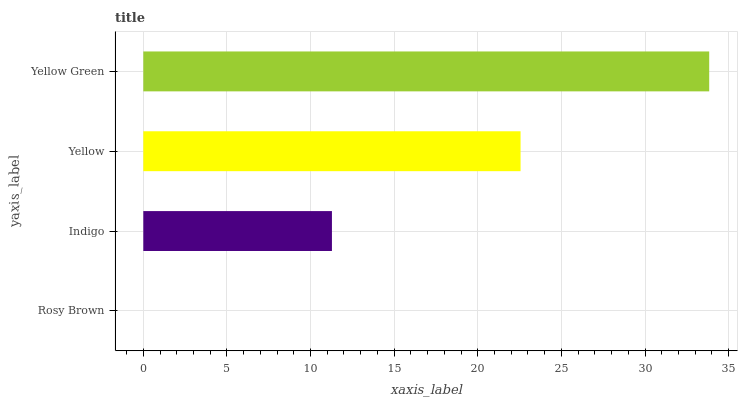Is Rosy Brown the minimum?
Answer yes or no. Yes. Is Yellow Green the maximum?
Answer yes or no. Yes. Is Indigo the minimum?
Answer yes or no. No. Is Indigo the maximum?
Answer yes or no. No. Is Indigo greater than Rosy Brown?
Answer yes or no. Yes. Is Rosy Brown less than Indigo?
Answer yes or no. Yes. Is Rosy Brown greater than Indigo?
Answer yes or no. No. Is Indigo less than Rosy Brown?
Answer yes or no. No. Is Yellow the high median?
Answer yes or no. Yes. Is Indigo the low median?
Answer yes or no. Yes. Is Yellow Green the high median?
Answer yes or no. No. Is Rosy Brown the low median?
Answer yes or no. No. 